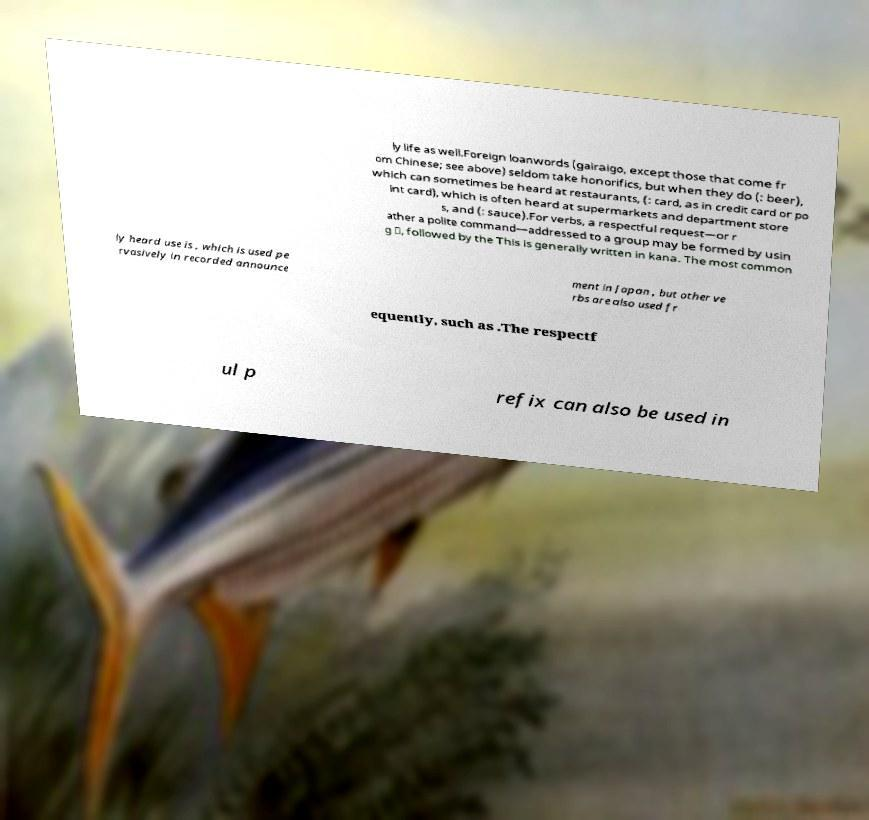Can you accurately transcribe the text from the provided image for me? ly life as well.Foreign loanwords (gairaigo, except those that come fr om Chinese; see above) seldom take honorifics, but when they do (: beer), which can sometimes be heard at restaurants, (: card, as in credit card or po int card), which is often heard at supermarkets and department store s, and (: sauce).For verbs, a respectful request—or r ather a polite command—addressed to a group may be formed by usin g 〜, followed by the This is generally written in kana. The most common ly heard use is , which is used pe rvasively in recorded announce ment in Japan , but other ve rbs are also used fr equently, such as .The respectf ul p refix can also be used in 